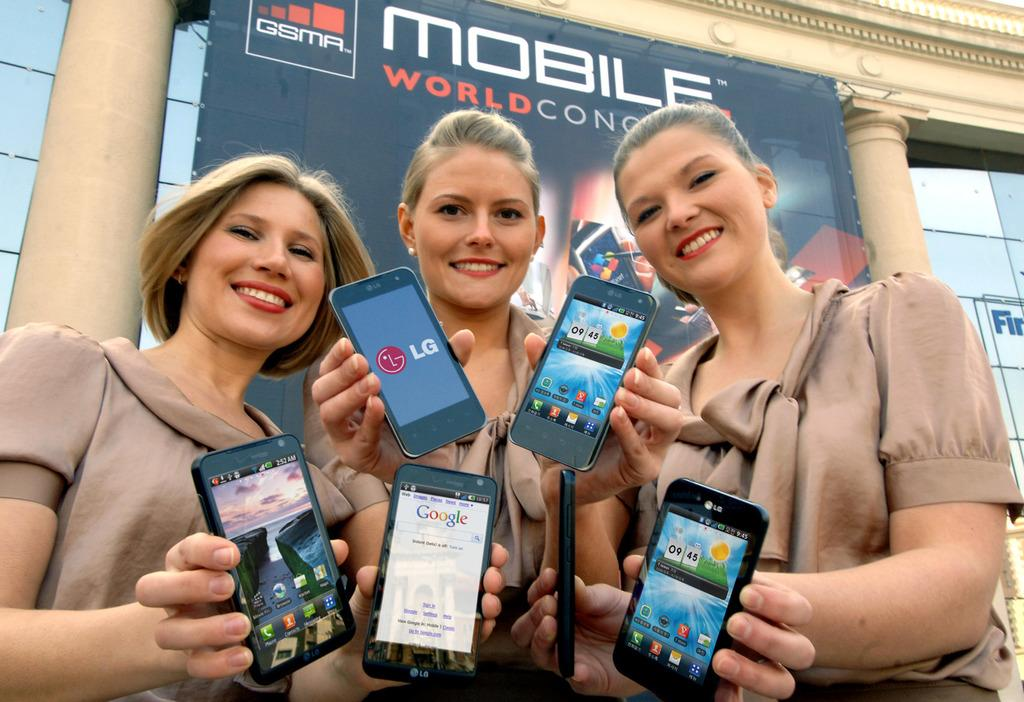<image>
Describe the image concisely. Three women holding cell phones in front of a sign that reads Mobile World Congress. 